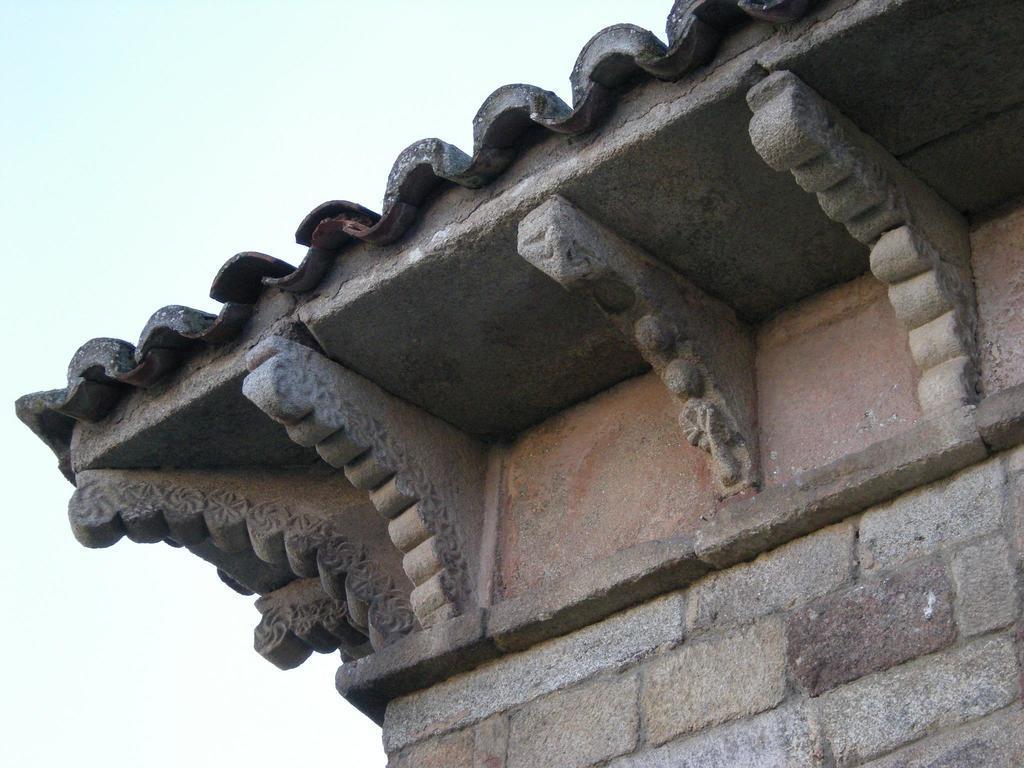Please provide a concise description of this image. In this picture I can see there is a building on right side and it has a roof, there is some sculpture on the roof. 